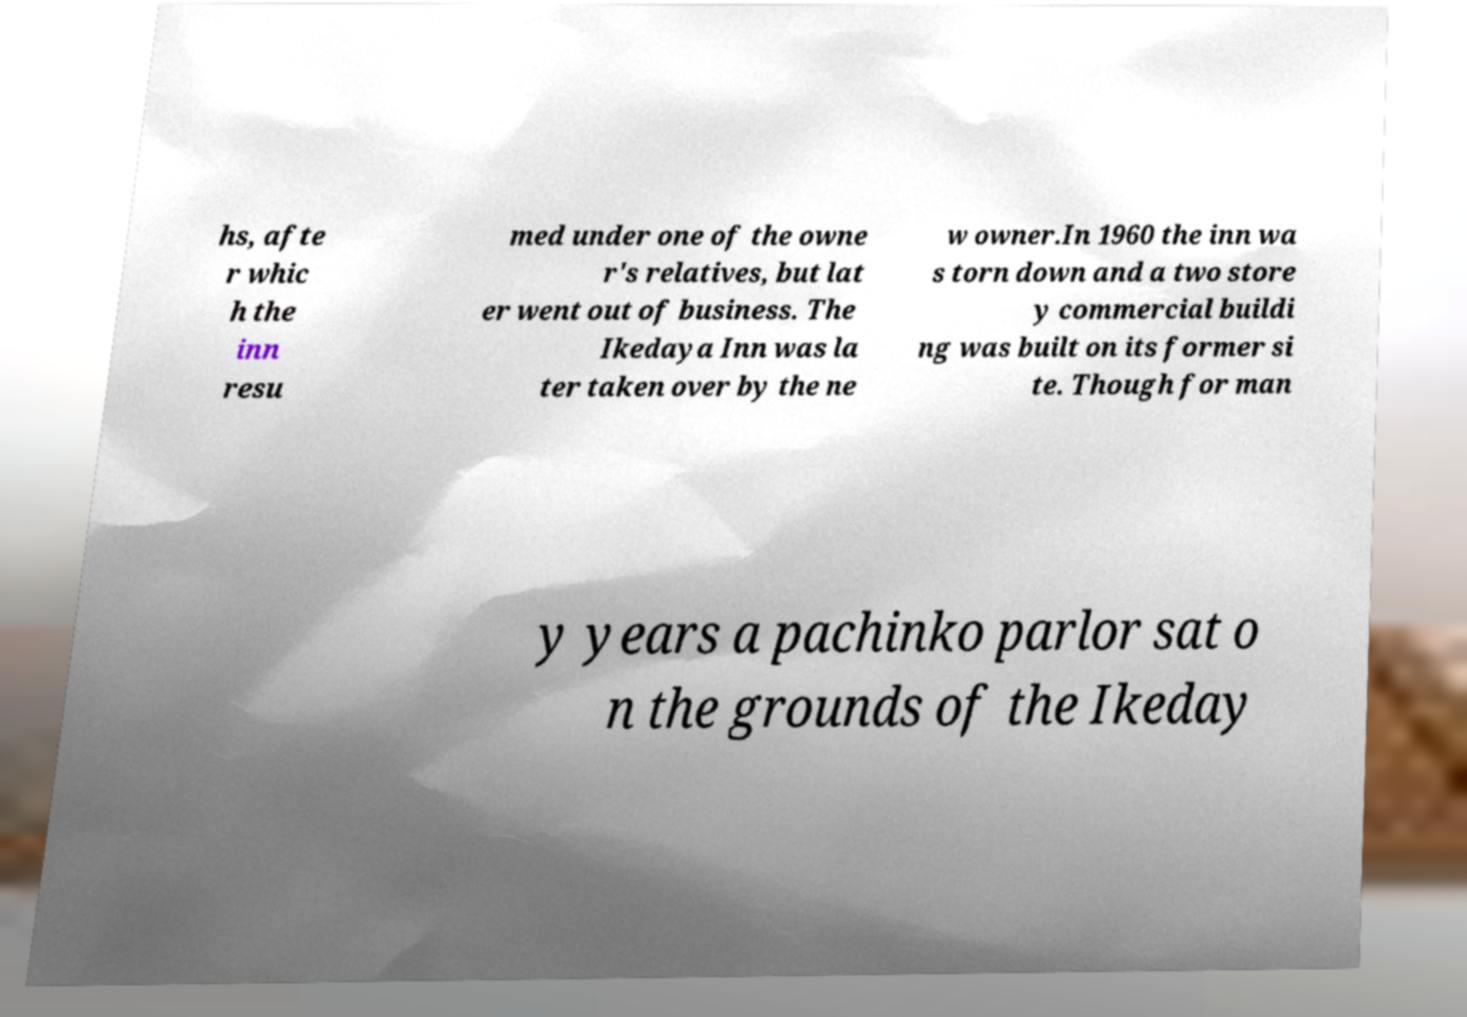I need the written content from this picture converted into text. Can you do that? hs, afte r whic h the inn resu med under one of the owne r's relatives, but lat er went out of business. The Ikedaya Inn was la ter taken over by the ne w owner.In 1960 the inn wa s torn down and a two store y commercial buildi ng was built on its former si te. Though for man y years a pachinko parlor sat o n the grounds of the Ikeday 